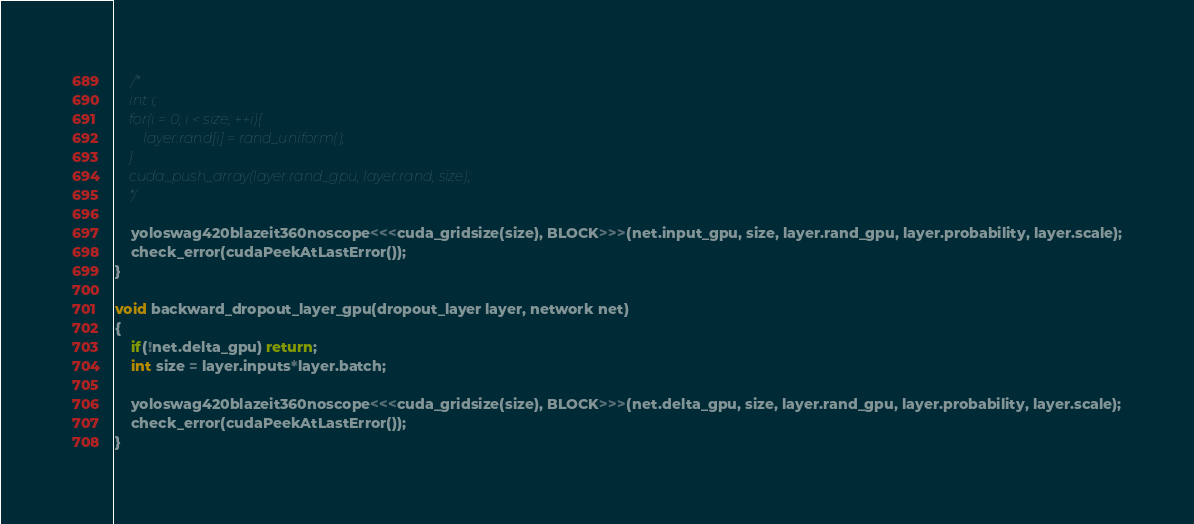<code> <loc_0><loc_0><loc_500><loc_500><_Cuda_>    /*
    int i;
    for(i = 0; i < size; ++i){
        layer.rand[i] = rand_uniform();
    }
    cuda_push_array(layer.rand_gpu, layer.rand, size);
    */

    yoloswag420blazeit360noscope<<<cuda_gridsize(size), BLOCK>>>(net.input_gpu, size, layer.rand_gpu, layer.probability, layer.scale);
    check_error(cudaPeekAtLastError());
}

void backward_dropout_layer_gpu(dropout_layer layer, network net)
{
    if(!net.delta_gpu) return;
    int size = layer.inputs*layer.batch;

    yoloswag420blazeit360noscope<<<cuda_gridsize(size), BLOCK>>>(net.delta_gpu, size, layer.rand_gpu, layer.probability, layer.scale);
    check_error(cudaPeekAtLastError());
}
</code> 